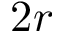Convert formula to latex. <formula><loc_0><loc_0><loc_500><loc_500>2 r</formula> 